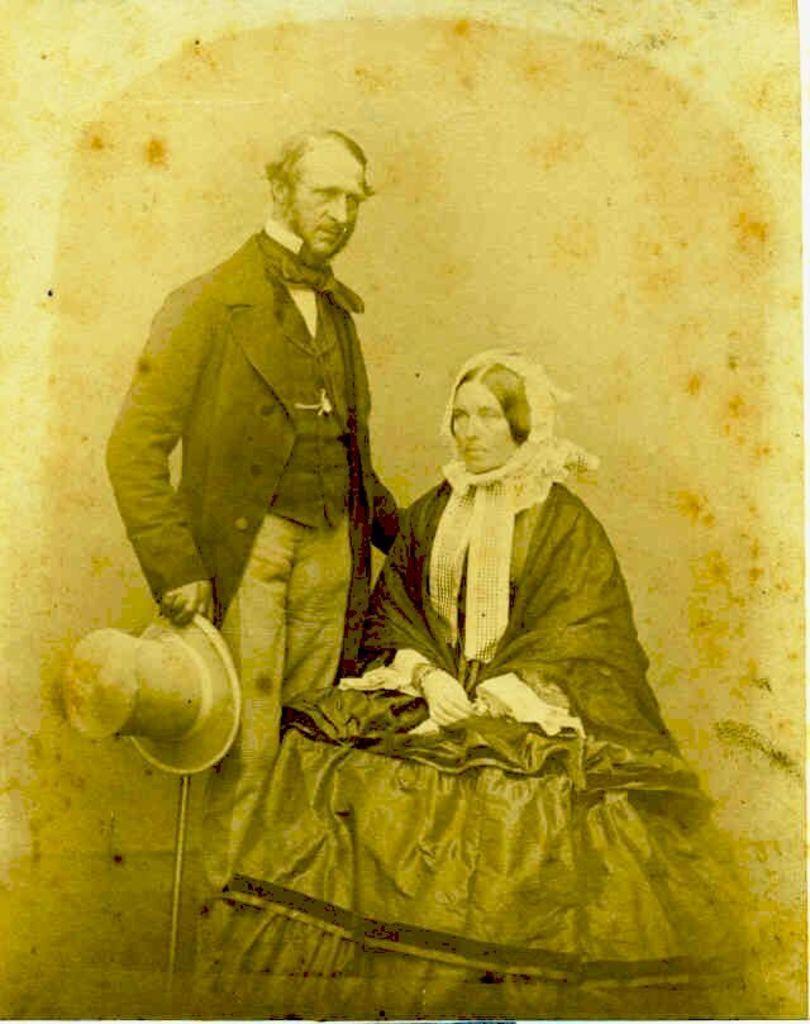Can you describe this image briefly? In this picture I can see there is a photograph of a man and a woman. The woman is sitting and wearing dress. The man is holding a cap. This is a very old image. 